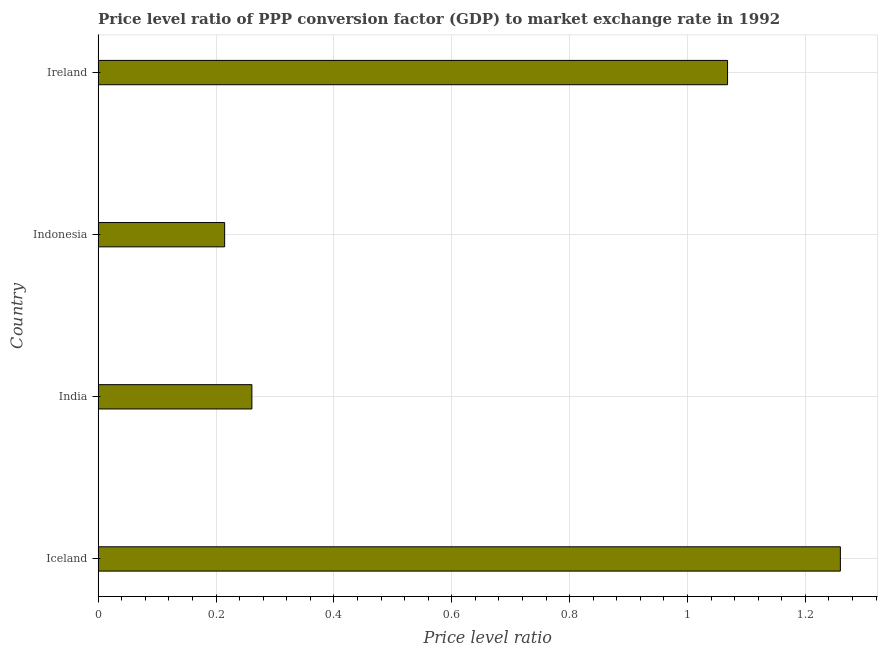What is the title of the graph?
Give a very brief answer. Price level ratio of PPP conversion factor (GDP) to market exchange rate in 1992. What is the label or title of the X-axis?
Provide a succinct answer. Price level ratio. What is the label or title of the Y-axis?
Your answer should be compact. Country. What is the price level ratio in Ireland?
Offer a very short reply. 1.07. Across all countries, what is the maximum price level ratio?
Offer a terse response. 1.26. Across all countries, what is the minimum price level ratio?
Your response must be concise. 0.21. In which country was the price level ratio maximum?
Give a very brief answer. Iceland. In which country was the price level ratio minimum?
Provide a succinct answer. Indonesia. What is the sum of the price level ratio?
Provide a short and direct response. 2.8. What is the difference between the price level ratio in India and Indonesia?
Offer a terse response. 0.05. What is the average price level ratio per country?
Offer a terse response. 0.7. What is the median price level ratio?
Your answer should be compact. 0.66. What is the ratio of the price level ratio in Iceland to that in Ireland?
Your answer should be compact. 1.18. Is the price level ratio in Iceland less than that in India?
Offer a terse response. No. What is the difference between the highest and the second highest price level ratio?
Provide a succinct answer. 0.19. Is the sum of the price level ratio in India and Indonesia greater than the maximum price level ratio across all countries?
Offer a very short reply. No. In how many countries, is the price level ratio greater than the average price level ratio taken over all countries?
Offer a terse response. 2. What is the Price level ratio of Iceland?
Offer a very short reply. 1.26. What is the Price level ratio in India?
Offer a very short reply. 0.26. What is the Price level ratio of Indonesia?
Keep it short and to the point. 0.21. What is the Price level ratio in Ireland?
Provide a succinct answer. 1.07. What is the difference between the Price level ratio in Iceland and India?
Your answer should be very brief. 1. What is the difference between the Price level ratio in Iceland and Indonesia?
Keep it short and to the point. 1.04. What is the difference between the Price level ratio in Iceland and Ireland?
Your answer should be very brief. 0.19. What is the difference between the Price level ratio in India and Indonesia?
Your answer should be very brief. 0.05. What is the difference between the Price level ratio in India and Ireland?
Keep it short and to the point. -0.81. What is the difference between the Price level ratio in Indonesia and Ireland?
Make the answer very short. -0.85. What is the ratio of the Price level ratio in Iceland to that in India?
Offer a terse response. 4.83. What is the ratio of the Price level ratio in Iceland to that in Indonesia?
Your answer should be very brief. 5.87. What is the ratio of the Price level ratio in Iceland to that in Ireland?
Provide a succinct answer. 1.18. What is the ratio of the Price level ratio in India to that in Indonesia?
Keep it short and to the point. 1.22. What is the ratio of the Price level ratio in India to that in Ireland?
Offer a very short reply. 0.24. What is the ratio of the Price level ratio in Indonesia to that in Ireland?
Ensure brevity in your answer.  0.2. 